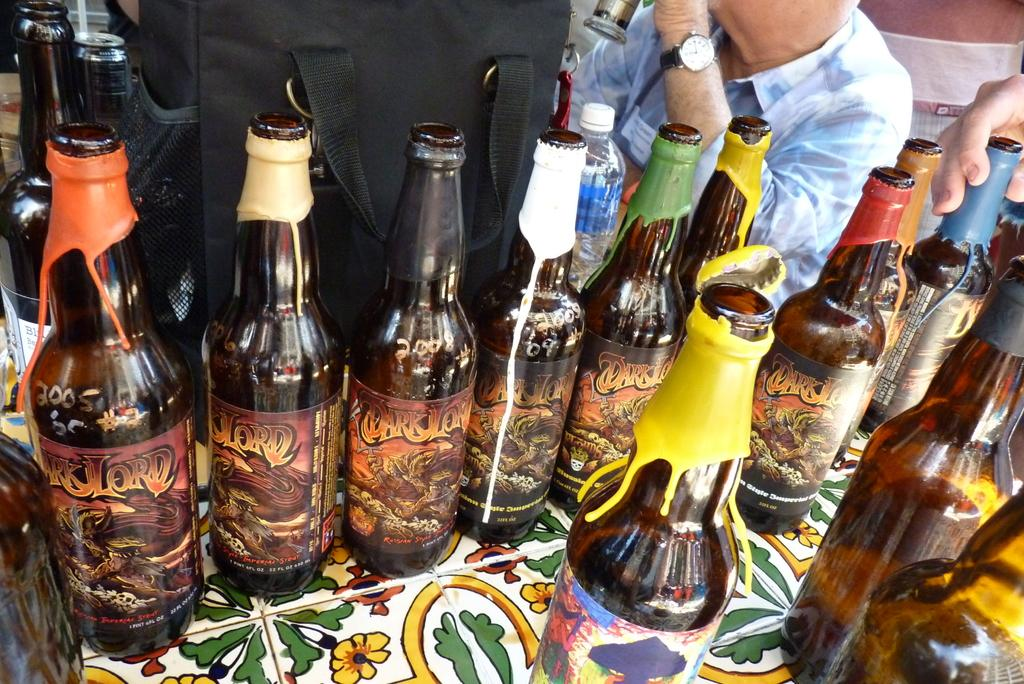What objects are on the table in the image? There are bottles with stickers on a table. What else can be seen in the image besides the table? There is a bag and a tin in the image. Can you describe the person in the image? The person is wearing a watch. What is the hand in the image doing? A hand is holding a bottle. Is there a stamp visible in the image? No, there is no stamp present in the image. 